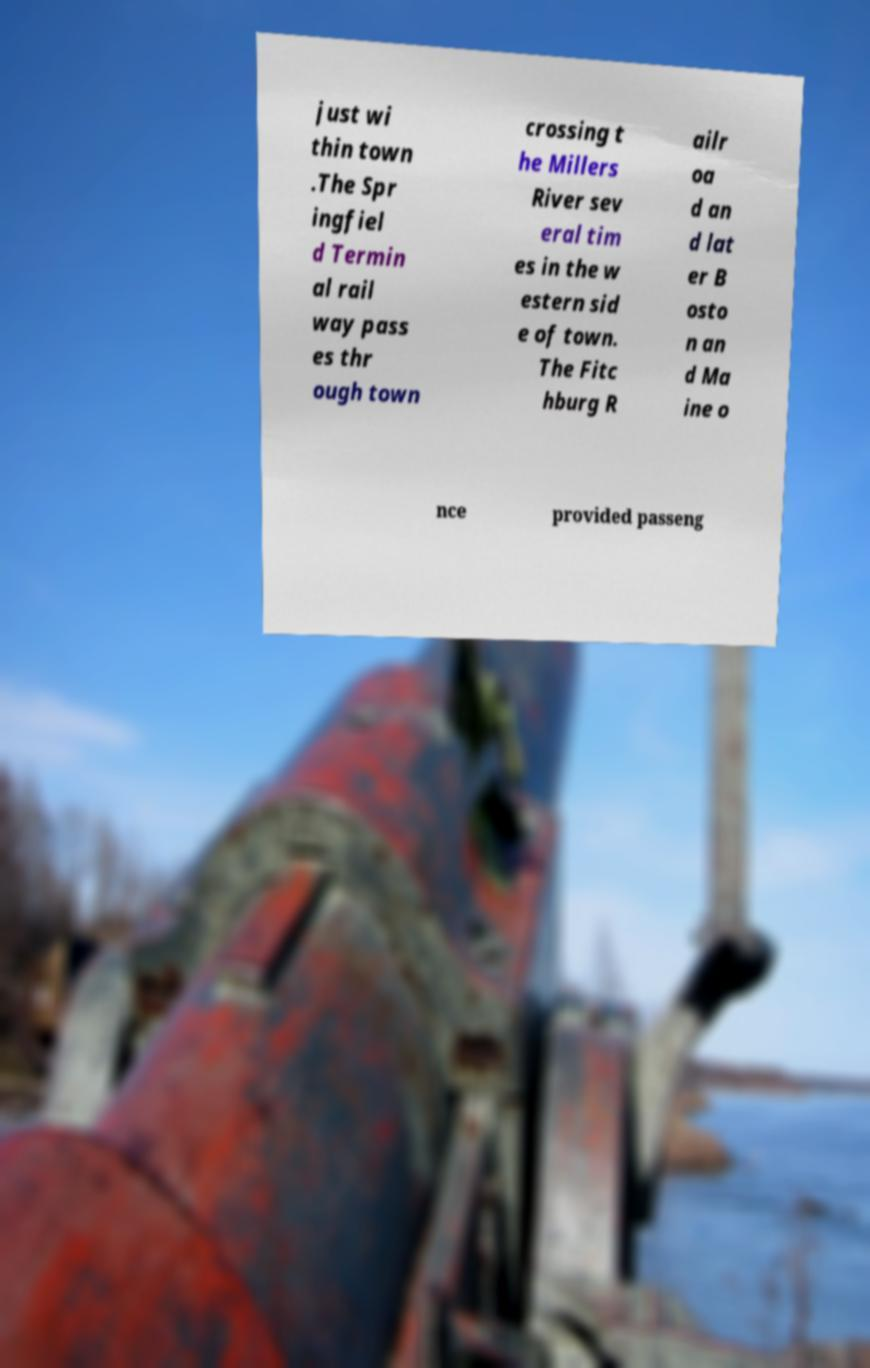Could you extract and type out the text from this image? just wi thin town .The Spr ingfiel d Termin al rail way pass es thr ough town crossing t he Millers River sev eral tim es in the w estern sid e of town. The Fitc hburg R ailr oa d an d lat er B osto n an d Ma ine o nce provided passeng 